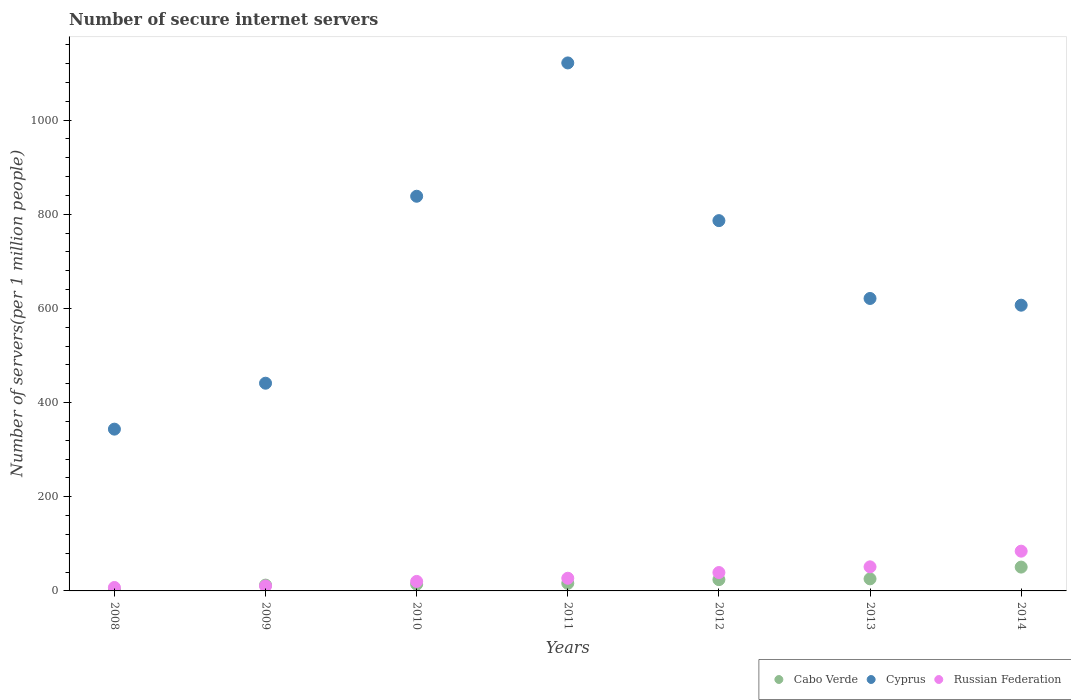How many different coloured dotlines are there?
Provide a short and direct response. 3. What is the number of secure internet servers in Russian Federation in 2012?
Your answer should be very brief. 39.04. Across all years, what is the maximum number of secure internet servers in Cabo Verde?
Provide a short and direct response. 50.59. Across all years, what is the minimum number of secure internet servers in Russian Federation?
Your response must be concise. 7.29. In which year was the number of secure internet servers in Russian Federation minimum?
Offer a terse response. 2008. What is the total number of secure internet servers in Cabo Verde in the graph?
Ensure brevity in your answer.  145.01. What is the difference between the number of secure internet servers in Cyprus in 2009 and that in 2014?
Your answer should be compact. -165.68. What is the difference between the number of secure internet servers in Cyprus in 2013 and the number of secure internet servers in Cabo Verde in 2010?
Offer a terse response. 606.76. What is the average number of secure internet servers in Russian Federation per year?
Offer a terse response. 34.21. In the year 2011, what is the difference between the number of secure internet servers in Cyprus and number of secure internet servers in Russian Federation?
Make the answer very short. 1094.29. What is the ratio of the number of secure internet servers in Cabo Verde in 2008 to that in 2012?
Make the answer very short. 0.09. Is the number of secure internet servers in Cabo Verde in 2009 less than that in 2014?
Provide a succinct answer. Yes. Is the difference between the number of secure internet servers in Cyprus in 2009 and 2014 greater than the difference between the number of secure internet servers in Russian Federation in 2009 and 2014?
Your response must be concise. No. What is the difference between the highest and the second highest number of secure internet servers in Russian Federation?
Provide a short and direct response. 33.28. What is the difference between the highest and the lowest number of secure internet servers in Cabo Verde?
Offer a terse response. 48.53. Is it the case that in every year, the sum of the number of secure internet servers in Cyprus and number of secure internet servers in Russian Federation  is greater than the number of secure internet servers in Cabo Verde?
Offer a very short reply. Yes. Does the number of secure internet servers in Russian Federation monotonically increase over the years?
Provide a succinct answer. Yes. Is the number of secure internet servers in Cabo Verde strictly greater than the number of secure internet servers in Russian Federation over the years?
Your answer should be very brief. No. How many years are there in the graph?
Offer a terse response. 7. What is the difference between two consecutive major ticks on the Y-axis?
Make the answer very short. 200. How are the legend labels stacked?
Make the answer very short. Horizontal. What is the title of the graph?
Keep it short and to the point. Number of secure internet servers. What is the label or title of the Y-axis?
Provide a succinct answer. Number of servers(per 1 million people). What is the Number of servers(per 1 million people) of Cabo Verde in 2008?
Offer a terse response. 2.07. What is the Number of servers(per 1 million people) in Cyprus in 2008?
Your answer should be compact. 343.54. What is the Number of servers(per 1 million people) in Russian Federation in 2008?
Your response must be concise. 7.29. What is the Number of servers(per 1 million people) in Cabo Verde in 2009?
Your answer should be very brief. 12.33. What is the Number of servers(per 1 million people) of Cyprus in 2009?
Give a very brief answer. 441.09. What is the Number of servers(per 1 million people) in Russian Federation in 2009?
Provide a short and direct response. 10.47. What is the Number of servers(per 1 million people) of Cabo Verde in 2010?
Your answer should be very brief. 14.27. What is the Number of servers(per 1 million people) of Cyprus in 2010?
Your answer should be compact. 838.1. What is the Number of servers(per 1 million people) in Russian Federation in 2010?
Provide a short and direct response. 20.19. What is the Number of servers(per 1 million people) of Cabo Verde in 2011?
Give a very brief answer. 16.16. What is the Number of servers(per 1 million people) in Cyprus in 2011?
Make the answer very short. 1121.22. What is the Number of servers(per 1 million people) in Russian Federation in 2011?
Give a very brief answer. 26.93. What is the Number of servers(per 1 million people) of Cabo Verde in 2012?
Your response must be concise. 23.96. What is the Number of servers(per 1 million people) of Cyprus in 2012?
Your response must be concise. 786.33. What is the Number of servers(per 1 million people) of Russian Federation in 2012?
Provide a short and direct response. 39.04. What is the Number of servers(per 1 million people) in Cabo Verde in 2013?
Keep it short and to the point. 25.63. What is the Number of servers(per 1 million people) in Cyprus in 2013?
Make the answer very short. 621.03. What is the Number of servers(per 1 million people) in Russian Federation in 2013?
Provide a short and direct response. 51.13. What is the Number of servers(per 1 million people) in Cabo Verde in 2014?
Provide a succinct answer. 50.59. What is the Number of servers(per 1 million people) of Cyprus in 2014?
Offer a very short reply. 606.77. What is the Number of servers(per 1 million people) of Russian Federation in 2014?
Provide a succinct answer. 84.42. Across all years, what is the maximum Number of servers(per 1 million people) in Cabo Verde?
Your answer should be compact. 50.59. Across all years, what is the maximum Number of servers(per 1 million people) in Cyprus?
Offer a very short reply. 1121.22. Across all years, what is the maximum Number of servers(per 1 million people) of Russian Federation?
Offer a very short reply. 84.42. Across all years, what is the minimum Number of servers(per 1 million people) of Cabo Verde?
Provide a succinct answer. 2.07. Across all years, what is the minimum Number of servers(per 1 million people) of Cyprus?
Make the answer very short. 343.54. Across all years, what is the minimum Number of servers(per 1 million people) in Russian Federation?
Your answer should be compact. 7.29. What is the total Number of servers(per 1 million people) in Cabo Verde in the graph?
Make the answer very short. 145.01. What is the total Number of servers(per 1 million people) in Cyprus in the graph?
Ensure brevity in your answer.  4758.07. What is the total Number of servers(per 1 million people) in Russian Federation in the graph?
Provide a succinct answer. 239.46. What is the difference between the Number of servers(per 1 million people) of Cabo Verde in 2008 and that in 2009?
Make the answer very short. -10.26. What is the difference between the Number of servers(per 1 million people) in Cyprus in 2008 and that in 2009?
Your response must be concise. -97.54. What is the difference between the Number of servers(per 1 million people) of Russian Federation in 2008 and that in 2009?
Your answer should be compact. -3.18. What is the difference between the Number of servers(per 1 million people) of Cabo Verde in 2008 and that in 2010?
Offer a very short reply. -12.21. What is the difference between the Number of servers(per 1 million people) of Cyprus in 2008 and that in 2010?
Give a very brief answer. -494.56. What is the difference between the Number of servers(per 1 million people) of Russian Federation in 2008 and that in 2010?
Offer a very short reply. -12.9. What is the difference between the Number of servers(per 1 million people) in Cabo Verde in 2008 and that in 2011?
Offer a very short reply. -14.09. What is the difference between the Number of servers(per 1 million people) of Cyprus in 2008 and that in 2011?
Your answer should be compact. -777.67. What is the difference between the Number of servers(per 1 million people) of Russian Federation in 2008 and that in 2011?
Your answer should be compact. -19.64. What is the difference between the Number of servers(per 1 million people) of Cabo Verde in 2008 and that in 2012?
Give a very brief answer. -21.89. What is the difference between the Number of servers(per 1 million people) of Cyprus in 2008 and that in 2012?
Offer a terse response. -442.78. What is the difference between the Number of servers(per 1 million people) in Russian Federation in 2008 and that in 2012?
Offer a terse response. -31.75. What is the difference between the Number of servers(per 1 million people) in Cabo Verde in 2008 and that in 2013?
Your answer should be very brief. -23.56. What is the difference between the Number of servers(per 1 million people) in Cyprus in 2008 and that in 2013?
Ensure brevity in your answer.  -277.49. What is the difference between the Number of servers(per 1 million people) in Russian Federation in 2008 and that in 2013?
Your response must be concise. -43.85. What is the difference between the Number of servers(per 1 million people) of Cabo Verde in 2008 and that in 2014?
Make the answer very short. -48.53. What is the difference between the Number of servers(per 1 million people) of Cyprus in 2008 and that in 2014?
Offer a terse response. -263.22. What is the difference between the Number of servers(per 1 million people) of Russian Federation in 2008 and that in 2014?
Your answer should be very brief. -77.13. What is the difference between the Number of servers(per 1 million people) in Cabo Verde in 2009 and that in 2010?
Offer a very short reply. -1.95. What is the difference between the Number of servers(per 1 million people) of Cyprus in 2009 and that in 2010?
Make the answer very short. -397.01. What is the difference between the Number of servers(per 1 million people) in Russian Federation in 2009 and that in 2010?
Make the answer very short. -9.72. What is the difference between the Number of servers(per 1 million people) in Cabo Verde in 2009 and that in 2011?
Make the answer very short. -3.83. What is the difference between the Number of servers(per 1 million people) in Cyprus in 2009 and that in 2011?
Keep it short and to the point. -680.13. What is the difference between the Number of servers(per 1 million people) in Russian Federation in 2009 and that in 2011?
Your answer should be very brief. -16.46. What is the difference between the Number of servers(per 1 million people) in Cabo Verde in 2009 and that in 2012?
Give a very brief answer. -11.63. What is the difference between the Number of servers(per 1 million people) in Cyprus in 2009 and that in 2012?
Give a very brief answer. -345.24. What is the difference between the Number of servers(per 1 million people) in Russian Federation in 2009 and that in 2012?
Your answer should be compact. -28.57. What is the difference between the Number of servers(per 1 million people) of Cabo Verde in 2009 and that in 2013?
Your answer should be very brief. -13.3. What is the difference between the Number of servers(per 1 million people) of Cyprus in 2009 and that in 2013?
Give a very brief answer. -179.94. What is the difference between the Number of servers(per 1 million people) in Russian Federation in 2009 and that in 2013?
Offer a terse response. -40.66. What is the difference between the Number of servers(per 1 million people) of Cabo Verde in 2009 and that in 2014?
Offer a terse response. -38.26. What is the difference between the Number of servers(per 1 million people) of Cyprus in 2009 and that in 2014?
Your answer should be compact. -165.68. What is the difference between the Number of servers(per 1 million people) in Russian Federation in 2009 and that in 2014?
Ensure brevity in your answer.  -73.95. What is the difference between the Number of servers(per 1 million people) of Cabo Verde in 2010 and that in 2011?
Provide a succinct answer. -1.88. What is the difference between the Number of servers(per 1 million people) of Cyprus in 2010 and that in 2011?
Keep it short and to the point. -283.12. What is the difference between the Number of servers(per 1 million people) of Russian Federation in 2010 and that in 2011?
Provide a succinct answer. -6.74. What is the difference between the Number of servers(per 1 million people) in Cabo Verde in 2010 and that in 2012?
Your response must be concise. -9.68. What is the difference between the Number of servers(per 1 million people) of Cyprus in 2010 and that in 2012?
Offer a terse response. 51.78. What is the difference between the Number of servers(per 1 million people) in Russian Federation in 2010 and that in 2012?
Offer a terse response. -18.85. What is the difference between the Number of servers(per 1 million people) in Cabo Verde in 2010 and that in 2013?
Provide a succinct answer. -11.35. What is the difference between the Number of servers(per 1 million people) of Cyprus in 2010 and that in 2013?
Offer a terse response. 217.07. What is the difference between the Number of servers(per 1 million people) in Russian Federation in 2010 and that in 2013?
Provide a succinct answer. -30.94. What is the difference between the Number of servers(per 1 million people) in Cabo Verde in 2010 and that in 2014?
Your answer should be compact. -36.32. What is the difference between the Number of servers(per 1 million people) in Cyprus in 2010 and that in 2014?
Give a very brief answer. 231.34. What is the difference between the Number of servers(per 1 million people) in Russian Federation in 2010 and that in 2014?
Make the answer very short. -64.23. What is the difference between the Number of servers(per 1 million people) of Cabo Verde in 2011 and that in 2012?
Offer a terse response. -7.8. What is the difference between the Number of servers(per 1 million people) of Cyprus in 2011 and that in 2012?
Provide a short and direct response. 334.89. What is the difference between the Number of servers(per 1 million people) in Russian Federation in 2011 and that in 2012?
Your answer should be very brief. -12.11. What is the difference between the Number of servers(per 1 million people) of Cabo Verde in 2011 and that in 2013?
Make the answer very short. -9.47. What is the difference between the Number of servers(per 1 million people) of Cyprus in 2011 and that in 2013?
Give a very brief answer. 500.19. What is the difference between the Number of servers(per 1 million people) in Russian Federation in 2011 and that in 2013?
Give a very brief answer. -24.2. What is the difference between the Number of servers(per 1 million people) in Cabo Verde in 2011 and that in 2014?
Make the answer very short. -34.44. What is the difference between the Number of servers(per 1 million people) of Cyprus in 2011 and that in 2014?
Keep it short and to the point. 514.45. What is the difference between the Number of servers(per 1 million people) of Russian Federation in 2011 and that in 2014?
Your answer should be very brief. -57.49. What is the difference between the Number of servers(per 1 million people) of Cabo Verde in 2012 and that in 2013?
Provide a short and direct response. -1.67. What is the difference between the Number of servers(per 1 million people) of Cyprus in 2012 and that in 2013?
Give a very brief answer. 165.3. What is the difference between the Number of servers(per 1 million people) in Russian Federation in 2012 and that in 2013?
Your answer should be very brief. -12.1. What is the difference between the Number of servers(per 1 million people) of Cabo Verde in 2012 and that in 2014?
Ensure brevity in your answer.  -26.63. What is the difference between the Number of servers(per 1 million people) in Cyprus in 2012 and that in 2014?
Provide a short and direct response. 179.56. What is the difference between the Number of servers(per 1 million people) of Russian Federation in 2012 and that in 2014?
Offer a terse response. -45.38. What is the difference between the Number of servers(per 1 million people) in Cabo Verde in 2013 and that in 2014?
Offer a terse response. -24.96. What is the difference between the Number of servers(per 1 million people) of Cyprus in 2013 and that in 2014?
Make the answer very short. 14.26. What is the difference between the Number of servers(per 1 million people) in Russian Federation in 2013 and that in 2014?
Your answer should be compact. -33.28. What is the difference between the Number of servers(per 1 million people) in Cabo Verde in 2008 and the Number of servers(per 1 million people) in Cyprus in 2009?
Your answer should be compact. -439.02. What is the difference between the Number of servers(per 1 million people) in Cabo Verde in 2008 and the Number of servers(per 1 million people) in Russian Federation in 2009?
Offer a very short reply. -8.4. What is the difference between the Number of servers(per 1 million people) of Cyprus in 2008 and the Number of servers(per 1 million people) of Russian Federation in 2009?
Your answer should be compact. 333.07. What is the difference between the Number of servers(per 1 million people) in Cabo Verde in 2008 and the Number of servers(per 1 million people) in Cyprus in 2010?
Provide a short and direct response. -836.03. What is the difference between the Number of servers(per 1 million people) in Cabo Verde in 2008 and the Number of servers(per 1 million people) in Russian Federation in 2010?
Make the answer very short. -18.12. What is the difference between the Number of servers(per 1 million people) of Cyprus in 2008 and the Number of servers(per 1 million people) of Russian Federation in 2010?
Offer a terse response. 323.35. What is the difference between the Number of servers(per 1 million people) of Cabo Verde in 2008 and the Number of servers(per 1 million people) of Cyprus in 2011?
Offer a terse response. -1119.15. What is the difference between the Number of servers(per 1 million people) in Cabo Verde in 2008 and the Number of servers(per 1 million people) in Russian Federation in 2011?
Provide a succinct answer. -24.86. What is the difference between the Number of servers(per 1 million people) of Cyprus in 2008 and the Number of servers(per 1 million people) of Russian Federation in 2011?
Provide a short and direct response. 316.61. What is the difference between the Number of servers(per 1 million people) of Cabo Verde in 2008 and the Number of servers(per 1 million people) of Cyprus in 2012?
Your answer should be compact. -784.26. What is the difference between the Number of servers(per 1 million people) of Cabo Verde in 2008 and the Number of servers(per 1 million people) of Russian Federation in 2012?
Your response must be concise. -36.97. What is the difference between the Number of servers(per 1 million people) of Cyprus in 2008 and the Number of servers(per 1 million people) of Russian Federation in 2012?
Provide a short and direct response. 304.51. What is the difference between the Number of servers(per 1 million people) in Cabo Verde in 2008 and the Number of servers(per 1 million people) in Cyprus in 2013?
Make the answer very short. -618.96. What is the difference between the Number of servers(per 1 million people) of Cabo Verde in 2008 and the Number of servers(per 1 million people) of Russian Federation in 2013?
Your answer should be very brief. -49.07. What is the difference between the Number of servers(per 1 million people) of Cyprus in 2008 and the Number of servers(per 1 million people) of Russian Federation in 2013?
Your answer should be compact. 292.41. What is the difference between the Number of servers(per 1 million people) of Cabo Verde in 2008 and the Number of servers(per 1 million people) of Cyprus in 2014?
Offer a very short reply. -604.7. What is the difference between the Number of servers(per 1 million people) of Cabo Verde in 2008 and the Number of servers(per 1 million people) of Russian Federation in 2014?
Provide a succinct answer. -82.35. What is the difference between the Number of servers(per 1 million people) of Cyprus in 2008 and the Number of servers(per 1 million people) of Russian Federation in 2014?
Give a very brief answer. 259.13. What is the difference between the Number of servers(per 1 million people) of Cabo Verde in 2009 and the Number of servers(per 1 million people) of Cyprus in 2010?
Provide a short and direct response. -825.77. What is the difference between the Number of servers(per 1 million people) of Cabo Verde in 2009 and the Number of servers(per 1 million people) of Russian Federation in 2010?
Ensure brevity in your answer.  -7.86. What is the difference between the Number of servers(per 1 million people) of Cyprus in 2009 and the Number of servers(per 1 million people) of Russian Federation in 2010?
Your answer should be very brief. 420.9. What is the difference between the Number of servers(per 1 million people) of Cabo Verde in 2009 and the Number of servers(per 1 million people) of Cyprus in 2011?
Provide a short and direct response. -1108.89. What is the difference between the Number of servers(per 1 million people) of Cabo Verde in 2009 and the Number of servers(per 1 million people) of Russian Federation in 2011?
Your answer should be very brief. -14.6. What is the difference between the Number of servers(per 1 million people) of Cyprus in 2009 and the Number of servers(per 1 million people) of Russian Federation in 2011?
Your response must be concise. 414.16. What is the difference between the Number of servers(per 1 million people) in Cabo Verde in 2009 and the Number of servers(per 1 million people) in Cyprus in 2012?
Provide a succinct answer. -774. What is the difference between the Number of servers(per 1 million people) in Cabo Verde in 2009 and the Number of servers(per 1 million people) in Russian Federation in 2012?
Your answer should be very brief. -26.71. What is the difference between the Number of servers(per 1 million people) in Cyprus in 2009 and the Number of servers(per 1 million people) in Russian Federation in 2012?
Give a very brief answer. 402.05. What is the difference between the Number of servers(per 1 million people) in Cabo Verde in 2009 and the Number of servers(per 1 million people) in Cyprus in 2013?
Your answer should be very brief. -608.7. What is the difference between the Number of servers(per 1 million people) in Cabo Verde in 2009 and the Number of servers(per 1 million people) in Russian Federation in 2013?
Provide a short and direct response. -38.8. What is the difference between the Number of servers(per 1 million people) in Cyprus in 2009 and the Number of servers(per 1 million people) in Russian Federation in 2013?
Provide a short and direct response. 389.95. What is the difference between the Number of servers(per 1 million people) of Cabo Verde in 2009 and the Number of servers(per 1 million people) of Cyprus in 2014?
Ensure brevity in your answer.  -594.44. What is the difference between the Number of servers(per 1 million people) in Cabo Verde in 2009 and the Number of servers(per 1 million people) in Russian Federation in 2014?
Provide a short and direct response. -72.09. What is the difference between the Number of servers(per 1 million people) of Cyprus in 2009 and the Number of servers(per 1 million people) of Russian Federation in 2014?
Keep it short and to the point. 356.67. What is the difference between the Number of servers(per 1 million people) in Cabo Verde in 2010 and the Number of servers(per 1 million people) in Cyprus in 2011?
Ensure brevity in your answer.  -1106.94. What is the difference between the Number of servers(per 1 million people) of Cabo Verde in 2010 and the Number of servers(per 1 million people) of Russian Federation in 2011?
Offer a very short reply. -12.66. What is the difference between the Number of servers(per 1 million people) of Cyprus in 2010 and the Number of servers(per 1 million people) of Russian Federation in 2011?
Offer a terse response. 811.17. What is the difference between the Number of servers(per 1 million people) of Cabo Verde in 2010 and the Number of servers(per 1 million people) of Cyprus in 2012?
Your answer should be very brief. -772.05. What is the difference between the Number of servers(per 1 million people) of Cabo Verde in 2010 and the Number of servers(per 1 million people) of Russian Federation in 2012?
Make the answer very short. -24.76. What is the difference between the Number of servers(per 1 million people) in Cyprus in 2010 and the Number of servers(per 1 million people) in Russian Federation in 2012?
Your answer should be compact. 799.07. What is the difference between the Number of servers(per 1 million people) in Cabo Verde in 2010 and the Number of servers(per 1 million people) in Cyprus in 2013?
Keep it short and to the point. -606.76. What is the difference between the Number of servers(per 1 million people) in Cabo Verde in 2010 and the Number of servers(per 1 million people) in Russian Federation in 2013?
Provide a succinct answer. -36.86. What is the difference between the Number of servers(per 1 million people) in Cyprus in 2010 and the Number of servers(per 1 million people) in Russian Federation in 2013?
Make the answer very short. 786.97. What is the difference between the Number of servers(per 1 million people) of Cabo Verde in 2010 and the Number of servers(per 1 million people) of Cyprus in 2014?
Make the answer very short. -592.49. What is the difference between the Number of servers(per 1 million people) in Cabo Verde in 2010 and the Number of servers(per 1 million people) in Russian Federation in 2014?
Ensure brevity in your answer.  -70.14. What is the difference between the Number of servers(per 1 million people) in Cyprus in 2010 and the Number of servers(per 1 million people) in Russian Federation in 2014?
Your answer should be compact. 753.68. What is the difference between the Number of servers(per 1 million people) of Cabo Verde in 2011 and the Number of servers(per 1 million people) of Cyprus in 2012?
Give a very brief answer. -770.17. What is the difference between the Number of servers(per 1 million people) in Cabo Verde in 2011 and the Number of servers(per 1 million people) in Russian Federation in 2012?
Ensure brevity in your answer.  -22.88. What is the difference between the Number of servers(per 1 million people) in Cyprus in 2011 and the Number of servers(per 1 million people) in Russian Federation in 2012?
Make the answer very short. 1082.18. What is the difference between the Number of servers(per 1 million people) of Cabo Verde in 2011 and the Number of servers(per 1 million people) of Cyprus in 2013?
Offer a terse response. -604.87. What is the difference between the Number of servers(per 1 million people) of Cabo Verde in 2011 and the Number of servers(per 1 million people) of Russian Federation in 2013?
Make the answer very short. -34.98. What is the difference between the Number of servers(per 1 million people) in Cyprus in 2011 and the Number of servers(per 1 million people) in Russian Federation in 2013?
Keep it short and to the point. 1070.08. What is the difference between the Number of servers(per 1 million people) in Cabo Verde in 2011 and the Number of servers(per 1 million people) in Cyprus in 2014?
Ensure brevity in your answer.  -590.61. What is the difference between the Number of servers(per 1 million people) of Cabo Verde in 2011 and the Number of servers(per 1 million people) of Russian Federation in 2014?
Offer a terse response. -68.26. What is the difference between the Number of servers(per 1 million people) in Cyprus in 2011 and the Number of servers(per 1 million people) in Russian Federation in 2014?
Give a very brief answer. 1036.8. What is the difference between the Number of servers(per 1 million people) of Cabo Verde in 2012 and the Number of servers(per 1 million people) of Cyprus in 2013?
Offer a very short reply. -597.07. What is the difference between the Number of servers(per 1 million people) in Cabo Verde in 2012 and the Number of servers(per 1 million people) in Russian Federation in 2013?
Provide a short and direct response. -27.18. What is the difference between the Number of servers(per 1 million people) of Cyprus in 2012 and the Number of servers(per 1 million people) of Russian Federation in 2013?
Your response must be concise. 735.19. What is the difference between the Number of servers(per 1 million people) in Cabo Verde in 2012 and the Number of servers(per 1 million people) in Cyprus in 2014?
Give a very brief answer. -582.81. What is the difference between the Number of servers(per 1 million people) of Cabo Verde in 2012 and the Number of servers(per 1 million people) of Russian Federation in 2014?
Your answer should be very brief. -60.46. What is the difference between the Number of servers(per 1 million people) of Cyprus in 2012 and the Number of servers(per 1 million people) of Russian Federation in 2014?
Your answer should be compact. 701.91. What is the difference between the Number of servers(per 1 million people) in Cabo Verde in 2013 and the Number of servers(per 1 million people) in Cyprus in 2014?
Offer a terse response. -581.14. What is the difference between the Number of servers(per 1 million people) of Cabo Verde in 2013 and the Number of servers(per 1 million people) of Russian Federation in 2014?
Keep it short and to the point. -58.79. What is the difference between the Number of servers(per 1 million people) in Cyprus in 2013 and the Number of servers(per 1 million people) in Russian Federation in 2014?
Ensure brevity in your answer.  536.61. What is the average Number of servers(per 1 million people) of Cabo Verde per year?
Your answer should be compact. 20.72. What is the average Number of servers(per 1 million people) of Cyprus per year?
Offer a very short reply. 679.72. What is the average Number of servers(per 1 million people) of Russian Federation per year?
Provide a succinct answer. 34.21. In the year 2008, what is the difference between the Number of servers(per 1 million people) in Cabo Verde and Number of servers(per 1 million people) in Cyprus?
Make the answer very short. -341.48. In the year 2008, what is the difference between the Number of servers(per 1 million people) in Cabo Verde and Number of servers(per 1 million people) in Russian Federation?
Offer a terse response. -5.22. In the year 2008, what is the difference between the Number of servers(per 1 million people) of Cyprus and Number of servers(per 1 million people) of Russian Federation?
Ensure brevity in your answer.  336.26. In the year 2009, what is the difference between the Number of servers(per 1 million people) of Cabo Verde and Number of servers(per 1 million people) of Cyprus?
Provide a short and direct response. -428.76. In the year 2009, what is the difference between the Number of servers(per 1 million people) in Cabo Verde and Number of servers(per 1 million people) in Russian Federation?
Keep it short and to the point. 1.86. In the year 2009, what is the difference between the Number of servers(per 1 million people) in Cyprus and Number of servers(per 1 million people) in Russian Federation?
Provide a succinct answer. 430.62. In the year 2010, what is the difference between the Number of servers(per 1 million people) in Cabo Verde and Number of servers(per 1 million people) in Cyprus?
Give a very brief answer. -823.83. In the year 2010, what is the difference between the Number of servers(per 1 million people) in Cabo Verde and Number of servers(per 1 million people) in Russian Federation?
Your response must be concise. -5.91. In the year 2010, what is the difference between the Number of servers(per 1 million people) of Cyprus and Number of servers(per 1 million people) of Russian Federation?
Your answer should be compact. 817.91. In the year 2011, what is the difference between the Number of servers(per 1 million people) of Cabo Verde and Number of servers(per 1 million people) of Cyprus?
Provide a succinct answer. -1105.06. In the year 2011, what is the difference between the Number of servers(per 1 million people) of Cabo Verde and Number of servers(per 1 million people) of Russian Federation?
Your answer should be compact. -10.77. In the year 2011, what is the difference between the Number of servers(per 1 million people) in Cyprus and Number of servers(per 1 million people) in Russian Federation?
Your response must be concise. 1094.29. In the year 2012, what is the difference between the Number of servers(per 1 million people) in Cabo Verde and Number of servers(per 1 million people) in Cyprus?
Your answer should be very brief. -762.37. In the year 2012, what is the difference between the Number of servers(per 1 million people) of Cabo Verde and Number of servers(per 1 million people) of Russian Federation?
Your response must be concise. -15.08. In the year 2012, what is the difference between the Number of servers(per 1 million people) in Cyprus and Number of servers(per 1 million people) in Russian Federation?
Ensure brevity in your answer.  747.29. In the year 2013, what is the difference between the Number of servers(per 1 million people) of Cabo Verde and Number of servers(per 1 million people) of Cyprus?
Give a very brief answer. -595.4. In the year 2013, what is the difference between the Number of servers(per 1 million people) of Cabo Verde and Number of servers(per 1 million people) of Russian Federation?
Offer a terse response. -25.51. In the year 2013, what is the difference between the Number of servers(per 1 million people) of Cyprus and Number of servers(per 1 million people) of Russian Federation?
Offer a terse response. 569.9. In the year 2014, what is the difference between the Number of servers(per 1 million people) in Cabo Verde and Number of servers(per 1 million people) in Cyprus?
Your answer should be compact. -556.17. In the year 2014, what is the difference between the Number of servers(per 1 million people) in Cabo Verde and Number of servers(per 1 million people) in Russian Federation?
Ensure brevity in your answer.  -33.83. In the year 2014, what is the difference between the Number of servers(per 1 million people) in Cyprus and Number of servers(per 1 million people) in Russian Federation?
Provide a short and direct response. 522.35. What is the ratio of the Number of servers(per 1 million people) in Cabo Verde in 2008 to that in 2009?
Keep it short and to the point. 0.17. What is the ratio of the Number of servers(per 1 million people) in Cyprus in 2008 to that in 2009?
Provide a short and direct response. 0.78. What is the ratio of the Number of servers(per 1 million people) in Russian Federation in 2008 to that in 2009?
Keep it short and to the point. 0.7. What is the ratio of the Number of servers(per 1 million people) of Cabo Verde in 2008 to that in 2010?
Give a very brief answer. 0.14. What is the ratio of the Number of servers(per 1 million people) of Cyprus in 2008 to that in 2010?
Your response must be concise. 0.41. What is the ratio of the Number of servers(per 1 million people) in Russian Federation in 2008 to that in 2010?
Offer a very short reply. 0.36. What is the ratio of the Number of servers(per 1 million people) in Cabo Verde in 2008 to that in 2011?
Your answer should be very brief. 0.13. What is the ratio of the Number of servers(per 1 million people) of Cyprus in 2008 to that in 2011?
Provide a succinct answer. 0.31. What is the ratio of the Number of servers(per 1 million people) of Russian Federation in 2008 to that in 2011?
Make the answer very short. 0.27. What is the ratio of the Number of servers(per 1 million people) in Cabo Verde in 2008 to that in 2012?
Your answer should be compact. 0.09. What is the ratio of the Number of servers(per 1 million people) of Cyprus in 2008 to that in 2012?
Your response must be concise. 0.44. What is the ratio of the Number of servers(per 1 million people) in Russian Federation in 2008 to that in 2012?
Ensure brevity in your answer.  0.19. What is the ratio of the Number of servers(per 1 million people) in Cabo Verde in 2008 to that in 2013?
Your answer should be very brief. 0.08. What is the ratio of the Number of servers(per 1 million people) in Cyprus in 2008 to that in 2013?
Ensure brevity in your answer.  0.55. What is the ratio of the Number of servers(per 1 million people) of Russian Federation in 2008 to that in 2013?
Give a very brief answer. 0.14. What is the ratio of the Number of servers(per 1 million people) in Cabo Verde in 2008 to that in 2014?
Offer a terse response. 0.04. What is the ratio of the Number of servers(per 1 million people) of Cyprus in 2008 to that in 2014?
Provide a short and direct response. 0.57. What is the ratio of the Number of servers(per 1 million people) of Russian Federation in 2008 to that in 2014?
Offer a very short reply. 0.09. What is the ratio of the Number of servers(per 1 million people) of Cabo Verde in 2009 to that in 2010?
Your answer should be compact. 0.86. What is the ratio of the Number of servers(per 1 million people) in Cyprus in 2009 to that in 2010?
Offer a very short reply. 0.53. What is the ratio of the Number of servers(per 1 million people) in Russian Federation in 2009 to that in 2010?
Your answer should be very brief. 0.52. What is the ratio of the Number of servers(per 1 million people) of Cabo Verde in 2009 to that in 2011?
Keep it short and to the point. 0.76. What is the ratio of the Number of servers(per 1 million people) in Cyprus in 2009 to that in 2011?
Provide a short and direct response. 0.39. What is the ratio of the Number of servers(per 1 million people) of Russian Federation in 2009 to that in 2011?
Offer a very short reply. 0.39. What is the ratio of the Number of servers(per 1 million people) in Cabo Verde in 2009 to that in 2012?
Ensure brevity in your answer.  0.51. What is the ratio of the Number of servers(per 1 million people) in Cyprus in 2009 to that in 2012?
Make the answer very short. 0.56. What is the ratio of the Number of servers(per 1 million people) in Russian Federation in 2009 to that in 2012?
Make the answer very short. 0.27. What is the ratio of the Number of servers(per 1 million people) in Cabo Verde in 2009 to that in 2013?
Make the answer very short. 0.48. What is the ratio of the Number of servers(per 1 million people) of Cyprus in 2009 to that in 2013?
Give a very brief answer. 0.71. What is the ratio of the Number of servers(per 1 million people) in Russian Federation in 2009 to that in 2013?
Ensure brevity in your answer.  0.2. What is the ratio of the Number of servers(per 1 million people) in Cabo Verde in 2009 to that in 2014?
Your answer should be compact. 0.24. What is the ratio of the Number of servers(per 1 million people) in Cyprus in 2009 to that in 2014?
Give a very brief answer. 0.73. What is the ratio of the Number of servers(per 1 million people) in Russian Federation in 2009 to that in 2014?
Make the answer very short. 0.12. What is the ratio of the Number of servers(per 1 million people) of Cabo Verde in 2010 to that in 2011?
Provide a succinct answer. 0.88. What is the ratio of the Number of servers(per 1 million people) in Cyprus in 2010 to that in 2011?
Give a very brief answer. 0.75. What is the ratio of the Number of servers(per 1 million people) in Russian Federation in 2010 to that in 2011?
Give a very brief answer. 0.75. What is the ratio of the Number of servers(per 1 million people) of Cabo Verde in 2010 to that in 2012?
Your answer should be compact. 0.6. What is the ratio of the Number of servers(per 1 million people) in Cyprus in 2010 to that in 2012?
Provide a short and direct response. 1.07. What is the ratio of the Number of servers(per 1 million people) of Russian Federation in 2010 to that in 2012?
Your response must be concise. 0.52. What is the ratio of the Number of servers(per 1 million people) of Cabo Verde in 2010 to that in 2013?
Provide a short and direct response. 0.56. What is the ratio of the Number of servers(per 1 million people) of Cyprus in 2010 to that in 2013?
Ensure brevity in your answer.  1.35. What is the ratio of the Number of servers(per 1 million people) of Russian Federation in 2010 to that in 2013?
Offer a terse response. 0.39. What is the ratio of the Number of servers(per 1 million people) in Cabo Verde in 2010 to that in 2014?
Give a very brief answer. 0.28. What is the ratio of the Number of servers(per 1 million people) of Cyprus in 2010 to that in 2014?
Offer a very short reply. 1.38. What is the ratio of the Number of servers(per 1 million people) in Russian Federation in 2010 to that in 2014?
Your answer should be very brief. 0.24. What is the ratio of the Number of servers(per 1 million people) in Cabo Verde in 2011 to that in 2012?
Give a very brief answer. 0.67. What is the ratio of the Number of servers(per 1 million people) of Cyprus in 2011 to that in 2012?
Your answer should be compact. 1.43. What is the ratio of the Number of servers(per 1 million people) in Russian Federation in 2011 to that in 2012?
Ensure brevity in your answer.  0.69. What is the ratio of the Number of servers(per 1 million people) in Cabo Verde in 2011 to that in 2013?
Provide a short and direct response. 0.63. What is the ratio of the Number of servers(per 1 million people) in Cyprus in 2011 to that in 2013?
Provide a succinct answer. 1.81. What is the ratio of the Number of servers(per 1 million people) of Russian Federation in 2011 to that in 2013?
Give a very brief answer. 0.53. What is the ratio of the Number of servers(per 1 million people) of Cabo Verde in 2011 to that in 2014?
Your answer should be compact. 0.32. What is the ratio of the Number of servers(per 1 million people) in Cyprus in 2011 to that in 2014?
Keep it short and to the point. 1.85. What is the ratio of the Number of servers(per 1 million people) of Russian Federation in 2011 to that in 2014?
Your answer should be very brief. 0.32. What is the ratio of the Number of servers(per 1 million people) in Cabo Verde in 2012 to that in 2013?
Provide a short and direct response. 0.93. What is the ratio of the Number of servers(per 1 million people) of Cyprus in 2012 to that in 2013?
Offer a very short reply. 1.27. What is the ratio of the Number of servers(per 1 million people) of Russian Federation in 2012 to that in 2013?
Keep it short and to the point. 0.76. What is the ratio of the Number of servers(per 1 million people) of Cabo Verde in 2012 to that in 2014?
Provide a succinct answer. 0.47. What is the ratio of the Number of servers(per 1 million people) of Cyprus in 2012 to that in 2014?
Your answer should be compact. 1.3. What is the ratio of the Number of servers(per 1 million people) of Russian Federation in 2012 to that in 2014?
Ensure brevity in your answer.  0.46. What is the ratio of the Number of servers(per 1 million people) of Cabo Verde in 2013 to that in 2014?
Your response must be concise. 0.51. What is the ratio of the Number of servers(per 1 million people) in Cyprus in 2013 to that in 2014?
Keep it short and to the point. 1.02. What is the ratio of the Number of servers(per 1 million people) in Russian Federation in 2013 to that in 2014?
Make the answer very short. 0.61. What is the difference between the highest and the second highest Number of servers(per 1 million people) in Cabo Verde?
Your answer should be compact. 24.96. What is the difference between the highest and the second highest Number of servers(per 1 million people) of Cyprus?
Provide a short and direct response. 283.12. What is the difference between the highest and the second highest Number of servers(per 1 million people) of Russian Federation?
Provide a succinct answer. 33.28. What is the difference between the highest and the lowest Number of servers(per 1 million people) in Cabo Verde?
Ensure brevity in your answer.  48.53. What is the difference between the highest and the lowest Number of servers(per 1 million people) of Cyprus?
Offer a very short reply. 777.67. What is the difference between the highest and the lowest Number of servers(per 1 million people) of Russian Federation?
Make the answer very short. 77.13. 